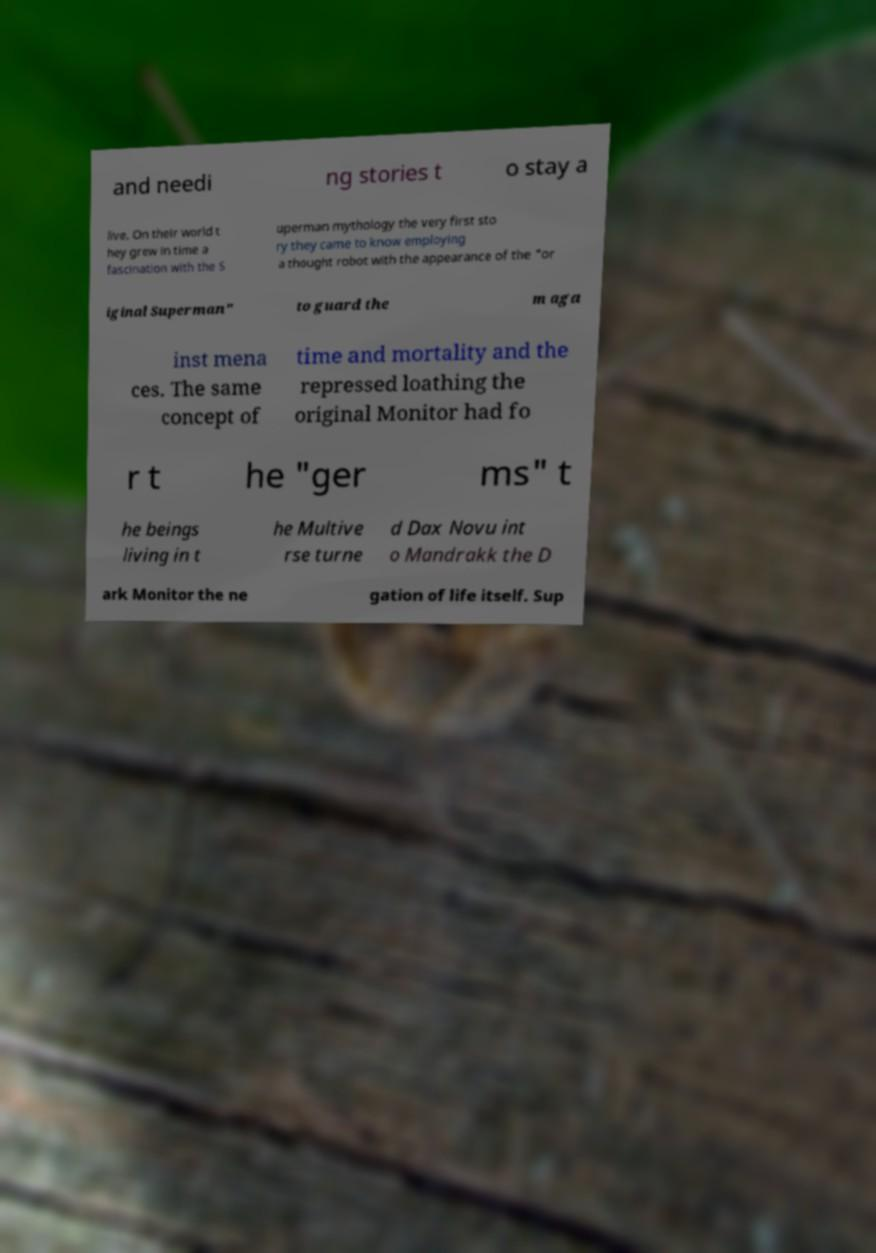Could you extract and type out the text from this image? and needi ng stories t o stay a live. On their world t hey grew in time a fascination with the S uperman mythology the very first sto ry they came to know employing a thought robot with the appearance of the "or iginal Superman" to guard the m aga inst mena ces. The same concept of time and mortality and the repressed loathing the original Monitor had fo r t he "ger ms" t he beings living in t he Multive rse turne d Dax Novu int o Mandrakk the D ark Monitor the ne gation of life itself. Sup 